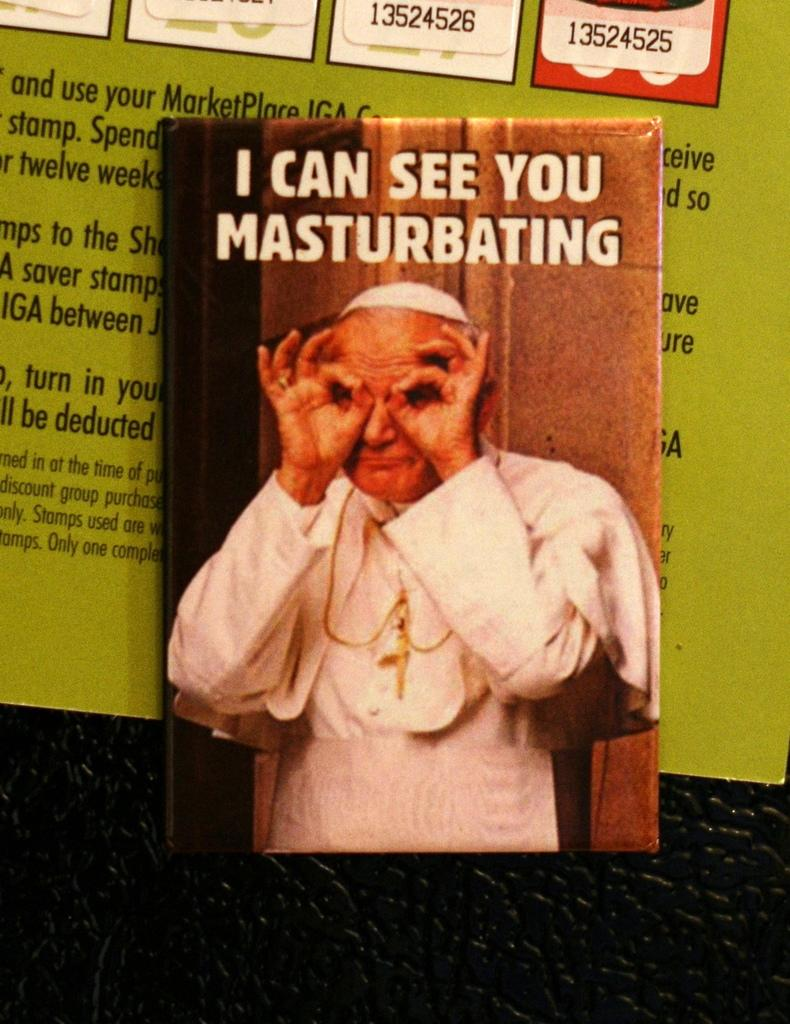How many books are visible in the image? There are two books in the image. Where are the books placed? The books are placed on an object. What is the color of the object on which the books are placed? The object is black in color. What can be seen on one of the books? There is an image of a person on one of the books. Is there any text on the book with the image? Yes, there is text on the book with the image. What type of parcel is being delivered to the person in the image? There is no parcel or delivery depicted in the image; it only shows two books with an image of a person and text. 